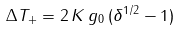<formula> <loc_0><loc_0><loc_500><loc_500>\Delta T _ { + } = 2 \, K \, g _ { 0 } \, ( \delta ^ { 1 / 2 } - 1 )</formula> 